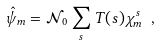<formula> <loc_0><loc_0><loc_500><loc_500>\hat { \psi } _ { m } = \mathcal { N } _ { 0 } \sum _ { s } T ( s ) \chi _ { m } ^ { s } \ ,</formula> 